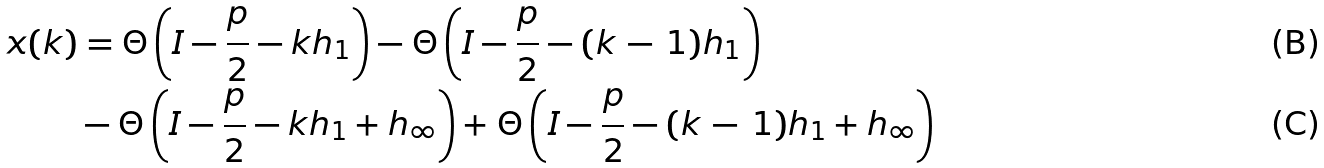<formula> <loc_0><loc_0><loc_500><loc_500>x ( k ) & = \Theta \left ( { I } - \frac { p } { 2 } - k { h } _ { 1 } \right ) - \Theta \left ( { I } - \frac { p } { 2 } - ( k \, - \, 1 ) { h } _ { 1 } \right ) \\ & - \Theta \left ( { I } - \frac { p } { 2 } - k { h } _ { 1 } + { h } _ { \infty } \right ) + \Theta \left ( { I } - \frac { p } { 2 } - ( k \, - \, 1 ) { h } _ { 1 } + { h } _ { \infty } \right )</formula> 